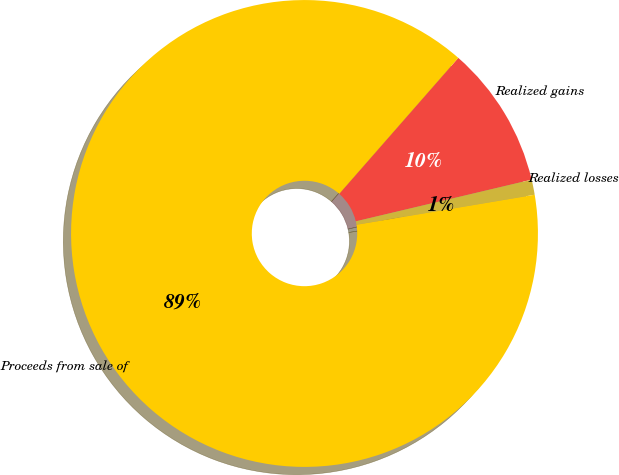Convert chart to OTSL. <chart><loc_0><loc_0><loc_500><loc_500><pie_chart><fcel>Realized gains<fcel>Realized losses<fcel>Proceeds from sale of<nl><fcel>9.85%<fcel>1.05%<fcel>89.1%<nl></chart> 